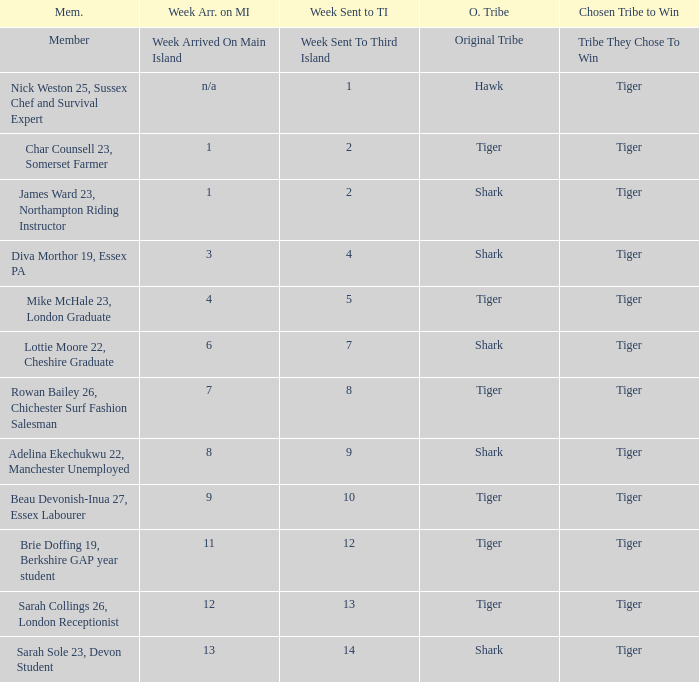How many members arrived on the main island in week 4? 1.0. 